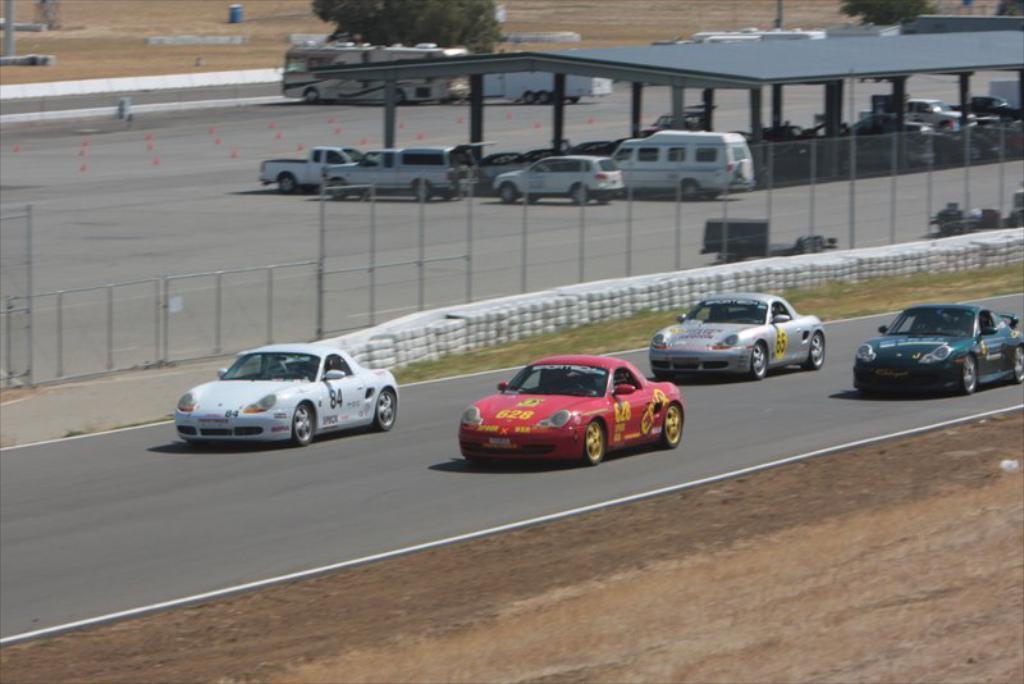Please provide a concise description of this image. This picture is clicked outside. In the center we can see the group of vehicles and we can see the mesh, metal rods, grass, shed and trees and many other objects. 